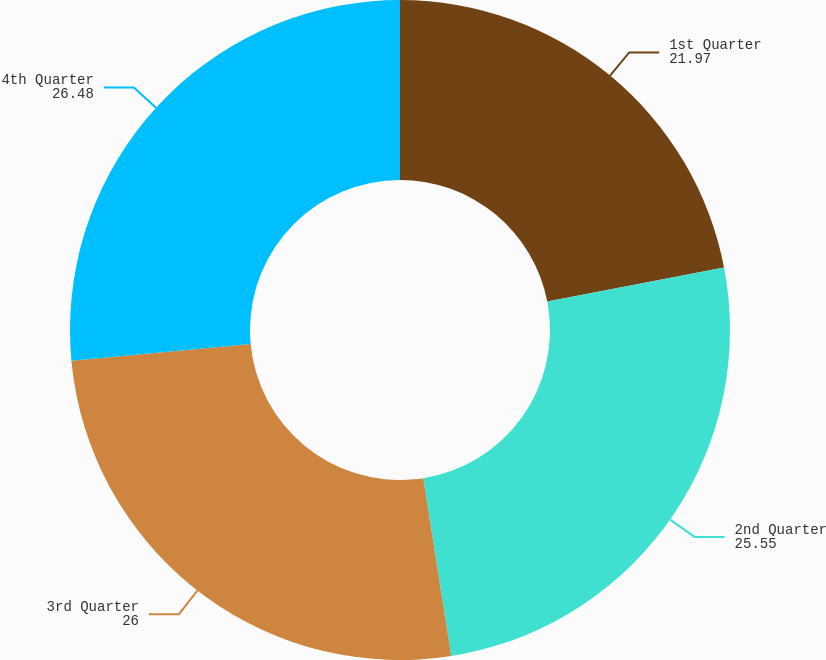Convert chart to OTSL. <chart><loc_0><loc_0><loc_500><loc_500><pie_chart><fcel>1st Quarter<fcel>2nd Quarter<fcel>3rd Quarter<fcel>4th Quarter<nl><fcel>21.97%<fcel>25.55%<fcel>26.0%<fcel>26.48%<nl></chart> 